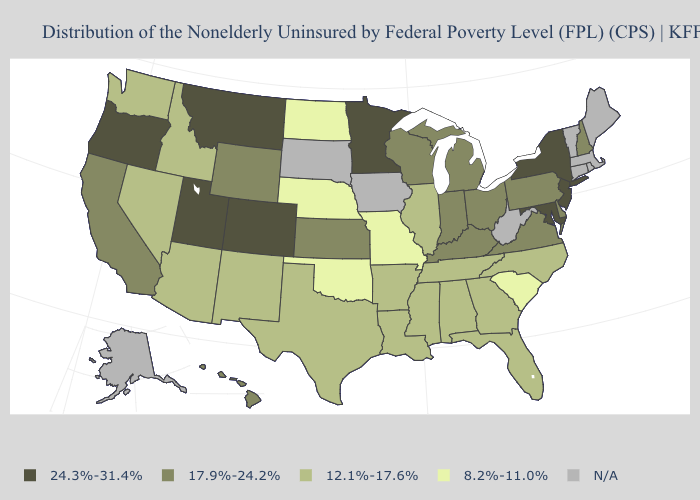What is the lowest value in the USA?
Short answer required. 8.2%-11.0%. Name the states that have a value in the range 24.3%-31.4%?
Be succinct. Colorado, Maryland, Minnesota, Montana, New Jersey, New York, Oregon, Utah. Name the states that have a value in the range N/A?
Quick response, please. Alaska, Connecticut, Iowa, Maine, Massachusetts, Rhode Island, South Dakota, Vermont, West Virginia. What is the value of North Carolina?
Keep it brief. 12.1%-17.6%. Among the states that border Connecticut , which have the highest value?
Keep it brief. New York. What is the value of Maine?
Be succinct. N/A. What is the value of Illinois?
Be succinct. 12.1%-17.6%. What is the lowest value in states that border South Carolina?
Concise answer only. 12.1%-17.6%. What is the value of Ohio?
Answer briefly. 17.9%-24.2%. Name the states that have a value in the range 24.3%-31.4%?
Give a very brief answer. Colorado, Maryland, Minnesota, Montana, New Jersey, New York, Oregon, Utah. Does the first symbol in the legend represent the smallest category?
Write a very short answer. No. Does the map have missing data?
Be succinct. Yes. Does North Dakota have the lowest value in the MidWest?
Concise answer only. Yes. What is the highest value in states that border Maryland?
Write a very short answer. 17.9%-24.2%. 